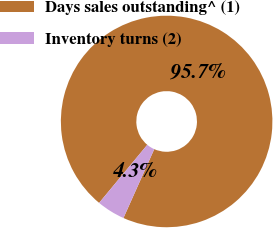Convert chart to OTSL. <chart><loc_0><loc_0><loc_500><loc_500><pie_chart><fcel>Days sales outstanding^ (1)<fcel>Inventory turns (2)<nl><fcel>95.68%<fcel>4.32%<nl></chart> 